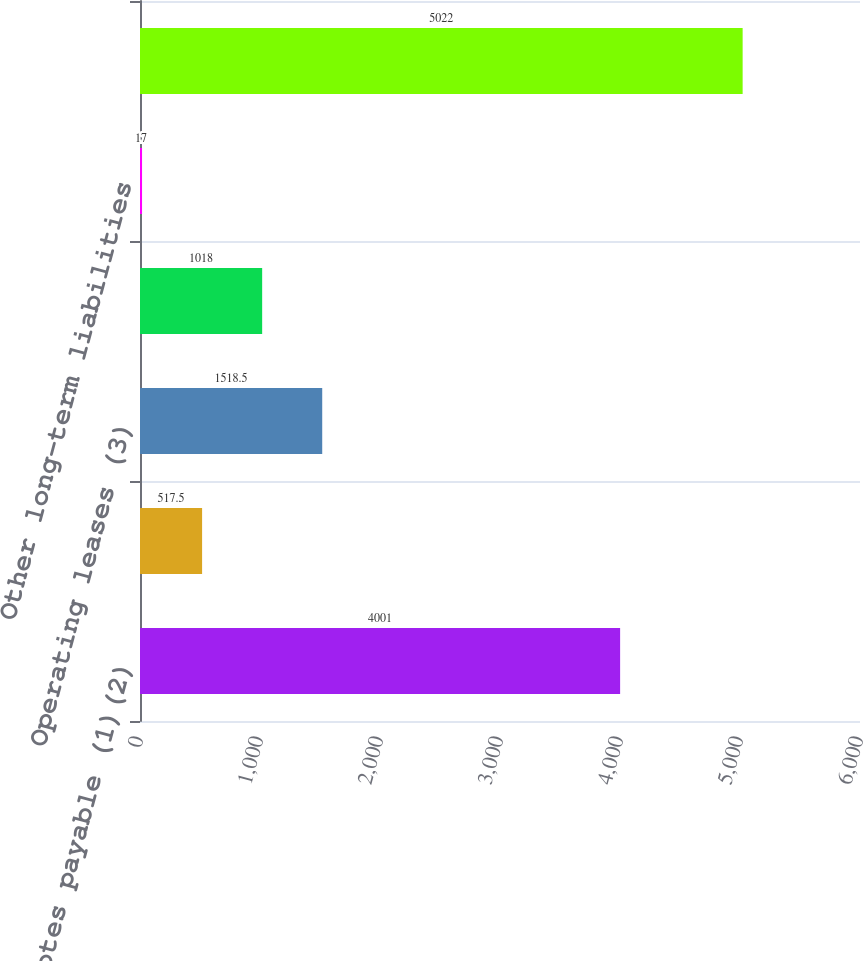Convert chart to OTSL. <chart><loc_0><loc_0><loc_500><loc_500><bar_chart><fcel>Notes payable (1)(2)<fcel>Capital lease obligations (2)<fcel>Operating leases (3)<fcel>Purchase obligations (4)<fcel>Other long-term liabilities<fcel>Total<nl><fcel>4001<fcel>517.5<fcel>1518.5<fcel>1018<fcel>17<fcel>5022<nl></chart> 